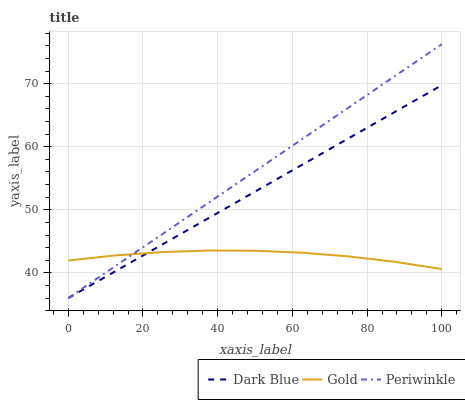Does Gold have the minimum area under the curve?
Answer yes or no. Yes. Does Periwinkle have the maximum area under the curve?
Answer yes or no. Yes. Does Periwinkle have the minimum area under the curve?
Answer yes or no. No. Does Gold have the maximum area under the curve?
Answer yes or no. No. Is Periwinkle the smoothest?
Answer yes or no. Yes. Is Gold the roughest?
Answer yes or no. Yes. Is Gold the smoothest?
Answer yes or no. No. Is Periwinkle the roughest?
Answer yes or no. No. Does Dark Blue have the lowest value?
Answer yes or no. Yes. Does Gold have the lowest value?
Answer yes or no. No. Does Periwinkle have the highest value?
Answer yes or no. Yes. Does Gold have the highest value?
Answer yes or no. No. Does Periwinkle intersect Dark Blue?
Answer yes or no. Yes. Is Periwinkle less than Dark Blue?
Answer yes or no. No. Is Periwinkle greater than Dark Blue?
Answer yes or no. No. 